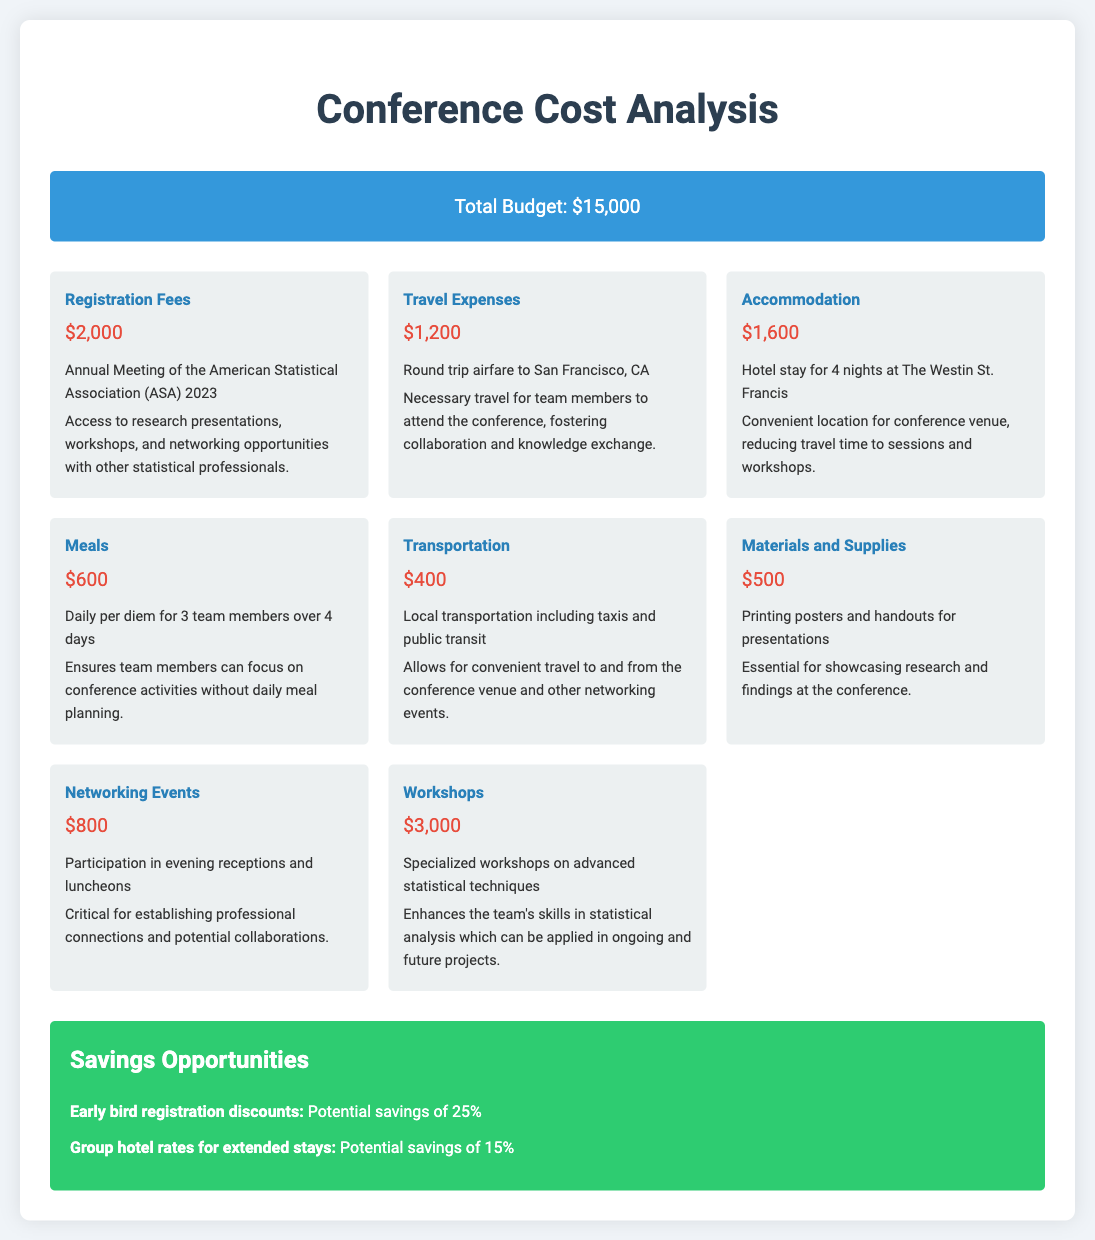what is the total budget? The total budget is stated at the top of the document in the budget summary section.
Answer: $15,000 how much was spent on registration fees? The registration fees were clearly listed as a separate expense item within the detailed breakdown of costs.
Answer: $2,000 what is the accommodation cost? The accommodation cost is outlined in the expenses section and indicates the price for a specific hotel stay.
Answer: $1,600 how many team members are covered for meals? This detail is mentioned in the expenses section, referring to the daily per diem allocation.
Answer: 3 team members what event required a $3,000 expense? The specific event that warranted this cost is detailed under the expenses category of workshops.
Answer: Workshops what justification is provided for local transportation costs? The expense justification explains the purpose of local transportation in relation to conference attendance.
Answer: Convenient travel to and from the conference venue and other networking events how much could be saved by early bird registration discounts? The savings potential is specifically noted for early registration within the savings opportunities section of the document.
Answer: 25% which hotel was chosen for accommodation? The document names the hotel where the team stayed during the conference in the accommodation expense item.
Answer: The Westin St. Francis what is the total amount spent on meals? The meals cost is listed as a specific expense and can be found in the expenses section.
Answer: $600 